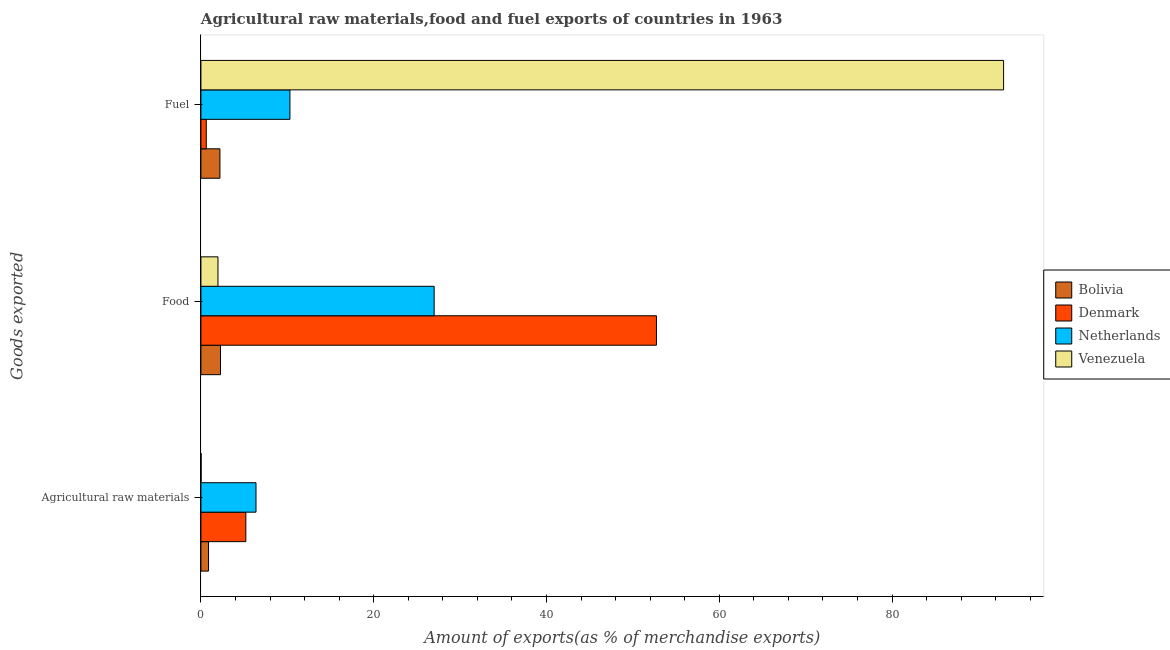How many groups of bars are there?
Your answer should be compact. 3. Are the number of bars per tick equal to the number of legend labels?
Provide a short and direct response. Yes. How many bars are there on the 3rd tick from the bottom?
Offer a very short reply. 4. What is the label of the 1st group of bars from the top?
Your answer should be compact. Fuel. What is the percentage of food exports in Netherlands?
Offer a terse response. 27. Across all countries, what is the maximum percentage of raw materials exports?
Offer a terse response. 6.38. Across all countries, what is the minimum percentage of food exports?
Make the answer very short. 1.97. In which country was the percentage of food exports maximum?
Provide a short and direct response. Denmark. In which country was the percentage of fuel exports minimum?
Make the answer very short. Denmark. What is the total percentage of raw materials exports in the graph?
Provide a succinct answer. 12.48. What is the difference between the percentage of raw materials exports in Venezuela and that in Netherlands?
Your answer should be compact. -6.35. What is the difference between the percentage of raw materials exports in Netherlands and the percentage of food exports in Denmark?
Your answer should be compact. -46.35. What is the average percentage of fuel exports per country?
Provide a succinct answer. 26.51. What is the difference between the percentage of fuel exports and percentage of raw materials exports in Denmark?
Provide a short and direct response. -4.58. What is the ratio of the percentage of fuel exports in Netherlands to that in Bolivia?
Your answer should be compact. 4.68. Is the difference between the percentage of food exports in Netherlands and Denmark greater than the difference between the percentage of fuel exports in Netherlands and Denmark?
Your answer should be very brief. No. What is the difference between the highest and the second highest percentage of food exports?
Make the answer very short. 25.73. What is the difference between the highest and the lowest percentage of raw materials exports?
Make the answer very short. 6.35. In how many countries, is the percentage of food exports greater than the average percentage of food exports taken over all countries?
Offer a very short reply. 2. What does the 2nd bar from the top in Fuel represents?
Your answer should be compact. Netherlands. What does the 3rd bar from the bottom in Food represents?
Give a very brief answer. Netherlands. Are all the bars in the graph horizontal?
Give a very brief answer. Yes. How many countries are there in the graph?
Your answer should be compact. 4. What is the difference between two consecutive major ticks on the X-axis?
Your response must be concise. 20. Are the values on the major ticks of X-axis written in scientific E-notation?
Ensure brevity in your answer.  No. Does the graph contain any zero values?
Give a very brief answer. No. Does the graph contain grids?
Give a very brief answer. No. Where does the legend appear in the graph?
Your answer should be compact. Center right. What is the title of the graph?
Offer a very short reply. Agricultural raw materials,food and fuel exports of countries in 1963. Does "Niger" appear as one of the legend labels in the graph?
Provide a short and direct response. No. What is the label or title of the X-axis?
Provide a succinct answer. Amount of exports(as % of merchandise exports). What is the label or title of the Y-axis?
Provide a succinct answer. Goods exported. What is the Amount of exports(as % of merchandise exports) of Bolivia in Agricultural raw materials?
Provide a succinct answer. 0.88. What is the Amount of exports(as % of merchandise exports) in Denmark in Agricultural raw materials?
Provide a short and direct response. 5.2. What is the Amount of exports(as % of merchandise exports) of Netherlands in Agricultural raw materials?
Provide a succinct answer. 6.38. What is the Amount of exports(as % of merchandise exports) of Venezuela in Agricultural raw materials?
Offer a very short reply. 0.03. What is the Amount of exports(as % of merchandise exports) of Bolivia in Food?
Your answer should be compact. 2.27. What is the Amount of exports(as % of merchandise exports) in Denmark in Food?
Provide a succinct answer. 52.73. What is the Amount of exports(as % of merchandise exports) of Netherlands in Food?
Your response must be concise. 27. What is the Amount of exports(as % of merchandise exports) of Venezuela in Food?
Give a very brief answer. 1.97. What is the Amount of exports(as % of merchandise exports) in Bolivia in Fuel?
Your answer should be very brief. 2.2. What is the Amount of exports(as % of merchandise exports) in Denmark in Fuel?
Give a very brief answer. 0.62. What is the Amount of exports(as % of merchandise exports) of Netherlands in Fuel?
Provide a short and direct response. 10.31. What is the Amount of exports(as % of merchandise exports) of Venezuela in Fuel?
Ensure brevity in your answer.  92.91. Across all Goods exported, what is the maximum Amount of exports(as % of merchandise exports) of Bolivia?
Your answer should be very brief. 2.27. Across all Goods exported, what is the maximum Amount of exports(as % of merchandise exports) of Denmark?
Offer a very short reply. 52.73. Across all Goods exported, what is the maximum Amount of exports(as % of merchandise exports) of Netherlands?
Provide a short and direct response. 27. Across all Goods exported, what is the maximum Amount of exports(as % of merchandise exports) in Venezuela?
Your response must be concise. 92.91. Across all Goods exported, what is the minimum Amount of exports(as % of merchandise exports) in Bolivia?
Provide a succinct answer. 0.88. Across all Goods exported, what is the minimum Amount of exports(as % of merchandise exports) in Denmark?
Offer a very short reply. 0.62. Across all Goods exported, what is the minimum Amount of exports(as % of merchandise exports) in Netherlands?
Give a very brief answer. 6.38. Across all Goods exported, what is the minimum Amount of exports(as % of merchandise exports) of Venezuela?
Provide a succinct answer. 0.03. What is the total Amount of exports(as % of merchandise exports) in Bolivia in the graph?
Keep it short and to the point. 5.35. What is the total Amount of exports(as % of merchandise exports) of Denmark in the graph?
Give a very brief answer. 58.55. What is the total Amount of exports(as % of merchandise exports) of Netherlands in the graph?
Give a very brief answer. 43.68. What is the total Amount of exports(as % of merchandise exports) in Venezuela in the graph?
Provide a short and direct response. 94.91. What is the difference between the Amount of exports(as % of merchandise exports) of Bolivia in Agricultural raw materials and that in Food?
Offer a very short reply. -1.38. What is the difference between the Amount of exports(as % of merchandise exports) of Denmark in Agricultural raw materials and that in Food?
Give a very brief answer. -47.53. What is the difference between the Amount of exports(as % of merchandise exports) in Netherlands in Agricultural raw materials and that in Food?
Ensure brevity in your answer.  -20.62. What is the difference between the Amount of exports(as % of merchandise exports) in Venezuela in Agricultural raw materials and that in Food?
Ensure brevity in your answer.  -1.95. What is the difference between the Amount of exports(as % of merchandise exports) of Bolivia in Agricultural raw materials and that in Fuel?
Provide a short and direct response. -1.32. What is the difference between the Amount of exports(as % of merchandise exports) of Denmark in Agricultural raw materials and that in Fuel?
Offer a very short reply. 4.58. What is the difference between the Amount of exports(as % of merchandise exports) in Netherlands in Agricultural raw materials and that in Fuel?
Ensure brevity in your answer.  -3.93. What is the difference between the Amount of exports(as % of merchandise exports) in Venezuela in Agricultural raw materials and that in Fuel?
Your response must be concise. -92.89. What is the difference between the Amount of exports(as % of merchandise exports) in Bolivia in Food and that in Fuel?
Offer a very short reply. 0.07. What is the difference between the Amount of exports(as % of merchandise exports) in Denmark in Food and that in Fuel?
Provide a succinct answer. 52.11. What is the difference between the Amount of exports(as % of merchandise exports) in Netherlands in Food and that in Fuel?
Your answer should be very brief. 16.69. What is the difference between the Amount of exports(as % of merchandise exports) in Venezuela in Food and that in Fuel?
Offer a terse response. -90.94. What is the difference between the Amount of exports(as % of merchandise exports) of Bolivia in Agricultural raw materials and the Amount of exports(as % of merchandise exports) of Denmark in Food?
Offer a very short reply. -51.85. What is the difference between the Amount of exports(as % of merchandise exports) of Bolivia in Agricultural raw materials and the Amount of exports(as % of merchandise exports) of Netherlands in Food?
Your answer should be very brief. -26.12. What is the difference between the Amount of exports(as % of merchandise exports) in Bolivia in Agricultural raw materials and the Amount of exports(as % of merchandise exports) in Venezuela in Food?
Keep it short and to the point. -1.09. What is the difference between the Amount of exports(as % of merchandise exports) in Denmark in Agricultural raw materials and the Amount of exports(as % of merchandise exports) in Netherlands in Food?
Your answer should be compact. -21.8. What is the difference between the Amount of exports(as % of merchandise exports) in Denmark in Agricultural raw materials and the Amount of exports(as % of merchandise exports) in Venezuela in Food?
Offer a very short reply. 3.23. What is the difference between the Amount of exports(as % of merchandise exports) of Netherlands in Agricultural raw materials and the Amount of exports(as % of merchandise exports) of Venezuela in Food?
Give a very brief answer. 4.4. What is the difference between the Amount of exports(as % of merchandise exports) in Bolivia in Agricultural raw materials and the Amount of exports(as % of merchandise exports) in Denmark in Fuel?
Make the answer very short. 0.26. What is the difference between the Amount of exports(as % of merchandise exports) in Bolivia in Agricultural raw materials and the Amount of exports(as % of merchandise exports) in Netherlands in Fuel?
Give a very brief answer. -9.42. What is the difference between the Amount of exports(as % of merchandise exports) of Bolivia in Agricultural raw materials and the Amount of exports(as % of merchandise exports) of Venezuela in Fuel?
Your response must be concise. -92.03. What is the difference between the Amount of exports(as % of merchandise exports) of Denmark in Agricultural raw materials and the Amount of exports(as % of merchandise exports) of Netherlands in Fuel?
Make the answer very short. -5.11. What is the difference between the Amount of exports(as % of merchandise exports) in Denmark in Agricultural raw materials and the Amount of exports(as % of merchandise exports) in Venezuela in Fuel?
Offer a terse response. -87.71. What is the difference between the Amount of exports(as % of merchandise exports) in Netherlands in Agricultural raw materials and the Amount of exports(as % of merchandise exports) in Venezuela in Fuel?
Offer a terse response. -86.53. What is the difference between the Amount of exports(as % of merchandise exports) of Bolivia in Food and the Amount of exports(as % of merchandise exports) of Denmark in Fuel?
Keep it short and to the point. 1.65. What is the difference between the Amount of exports(as % of merchandise exports) in Bolivia in Food and the Amount of exports(as % of merchandise exports) in Netherlands in Fuel?
Ensure brevity in your answer.  -8.04. What is the difference between the Amount of exports(as % of merchandise exports) of Bolivia in Food and the Amount of exports(as % of merchandise exports) of Venezuela in Fuel?
Ensure brevity in your answer.  -90.65. What is the difference between the Amount of exports(as % of merchandise exports) of Denmark in Food and the Amount of exports(as % of merchandise exports) of Netherlands in Fuel?
Your response must be concise. 42.42. What is the difference between the Amount of exports(as % of merchandise exports) of Denmark in Food and the Amount of exports(as % of merchandise exports) of Venezuela in Fuel?
Your answer should be very brief. -40.18. What is the difference between the Amount of exports(as % of merchandise exports) in Netherlands in Food and the Amount of exports(as % of merchandise exports) in Venezuela in Fuel?
Provide a short and direct response. -65.91. What is the average Amount of exports(as % of merchandise exports) of Bolivia per Goods exported?
Provide a succinct answer. 1.78. What is the average Amount of exports(as % of merchandise exports) in Denmark per Goods exported?
Keep it short and to the point. 19.52. What is the average Amount of exports(as % of merchandise exports) of Netherlands per Goods exported?
Keep it short and to the point. 14.56. What is the average Amount of exports(as % of merchandise exports) in Venezuela per Goods exported?
Keep it short and to the point. 31.64. What is the difference between the Amount of exports(as % of merchandise exports) in Bolivia and Amount of exports(as % of merchandise exports) in Denmark in Agricultural raw materials?
Offer a terse response. -4.32. What is the difference between the Amount of exports(as % of merchandise exports) of Bolivia and Amount of exports(as % of merchandise exports) of Netherlands in Agricultural raw materials?
Offer a very short reply. -5.5. What is the difference between the Amount of exports(as % of merchandise exports) of Bolivia and Amount of exports(as % of merchandise exports) of Venezuela in Agricultural raw materials?
Your response must be concise. 0.86. What is the difference between the Amount of exports(as % of merchandise exports) of Denmark and Amount of exports(as % of merchandise exports) of Netherlands in Agricultural raw materials?
Provide a succinct answer. -1.18. What is the difference between the Amount of exports(as % of merchandise exports) of Denmark and Amount of exports(as % of merchandise exports) of Venezuela in Agricultural raw materials?
Ensure brevity in your answer.  5.17. What is the difference between the Amount of exports(as % of merchandise exports) of Netherlands and Amount of exports(as % of merchandise exports) of Venezuela in Agricultural raw materials?
Make the answer very short. 6.35. What is the difference between the Amount of exports(as % of merchandise exports) of Bolivia and Amount of exports(as % of merchandise exports) of Denmark in Food?
Provide a short and direct response. -50.46. What is the difference between the Amount of exports(as % of merchandise exports) in Bolivia and Amount of exports(as % of merchandise exports) in Netherlands in Food?
Offer a very short reply. -24.73. What is the difference between the Amount of exports(as % of merchandise exports) of Bolivia and Amount of exports(as % of merchandise exports) of Venezuela in Food?
Your answer should be very brief. 0.29. What is the difference between the Amount of exports(as % of merchandise exports) of Denmark and Amount of exports(as % of merchandise exports) of Netherlands in Food?
Provide a succinct answer. 25.73. What is the difference between the Amount of exports(as % of merchandise exports) of Denmark and Amount of exports(as % of merchandise exports) of Venezuela in Food?
Offer a very short reply. 50.76. What is the difference between the Amount of exports(as % of merchandise exports) in Netherlands and Amount of exports(as % of merchandise exports) in Venezuela in Food?
Your answer should be compact. 25.02. What is the difference between the Amount of exports(as % of merchandise exports) of Bolivia and Amount of exports(as % of merchandise exports) of Denmark in Fuel?
Ensure brevity in your answer.  1.58. What is the difference between the Amount of exports(as % of merchandise exports) of Bolivia and Amount of exports(as % of merchandise exports) of Netherlands in Fuel?
Your answer should be very brief. -8.1. What is the difference between the Amount of exports(as % of merchandise exports) of Bolivia and Amount of exports(as % of merchandise exports) of Venezuela in Fuel?
Keep it short and to the point. -90.71. What is the difference between the Amount of exports(as % of merchandise exports) of Denmark and Amount of exports(as % of merchandise exports) of Netherlands in Fuel?
Your answer should be compact. -9.68. What is the difference between the Amount of exports(as % of merchandise exports) of Denmark and Amount of exports(as % of merchandise exports) of Venezuela in Fuel?
Make the answer very short. -92.29. What is the difference between the Amount of exports(as % of merchandise exports) of Netherlands and Amount of exports(as % of merchandise exports) of Venezuela in Fuel?
Offer a terse response. -82.61. What is the ratio of the Amount of exports(as % of merchandise exports) in Bolivia in Agricultural raw materials to that in Food?
Make the answer very short. 0.39. What is the ratio of the Amount of exports(as % of merchandise exports) in Denmark in Agricultural raw materials to that in Food?
Provide a succinct answer. 0.1. What is the ratio of the Amount of exports(as % of merchandise exports) in Netherlands in Agricultural raw materials to that in Food?
Your answer should be compact. 0.24. What is the ratio of the Amount of exports(as % of merchandise exports) in Venezuela in Agricultural raw materials to that in Food?
Provide a succinct answer. 0.01. What is the ratio of the Amount of exports(as % of merchandise exports) in Bolivia in Agricultural raw materials to that in Fuel?
Provide a succinct answer. 0.4. What is the ratio of the Amount of exports(as % of merchandise exports) in Denmark in Agricultural raw materials to that in Fuel?
Ensure brevity in your answer.  8.38. What is the ratio of the Amount of exports(as % of merchandise exports) of Netherlands in Agricultural raw materials to that in Fuel?
Offer a very short reply. 0.62. What is the ratio of the Amount of exports(as % of merchandise exports) in Venezuela in Agricultural raw materials to that in Fuel?
Your response must be concise. 0. What is the ratio of the Amount of exports(as % of merchandise exports) of Bolivia in Food to that in Fuel?
Keep it short and to the point. 1.03. What is the ratio of the Amount of exports(as % of merchandise exports) of Denmark in Food to that in Fuel?
Ensure brevity in your answer.  85.01. What is the ratio of the Amount of exports(as % of merchandise exports) of Netherlands in Food to that in Fuel?
Keep it short and to the point. 2.62. What is the ratio of the Amount of exports(as % of merchandise exports) in Venezuela in Food to that in Fuel?
Provide a short and direct response. 0.02. What is the difference between the highest and the second highest Amount of exports(as % of merchandise exports) of Bolivia?
Provide a succinct answer. 0.07. What is the difference between the highest and the second highest Amount of exports(as % of merchandise exports) of Denmark?
Give a very brief answer. 47.53. What is the difference between the highest and the second highest Amount of exports(as % of merchandise exports) of Netherlands?
Make the answer very short. 16.69. What is the difference between the highest and the second highest Amount of exports(as % of merchandise exports) in Venezuela?
Your response must be concise. 90.94. What is the difference between the highest and the lowest Amount of exports(as % of merchandise exports) in Bolivia?
Provide a short and direct response. 1.38. What is the difference between the highest and the lowest Amount of exports(as % of merchandise exports) of Denmark?
Give a very brief answer. 52.11. What is the difference between the highest and the lowest Amount of exports(as % of merchandise exports) of Netherlands?
Your response must be concise. 20.62. What is the difference between the highest and the lowest Amount of exports(as % of merchandise exports) of Venezuela?
Give a very brief answer. 92.89. 